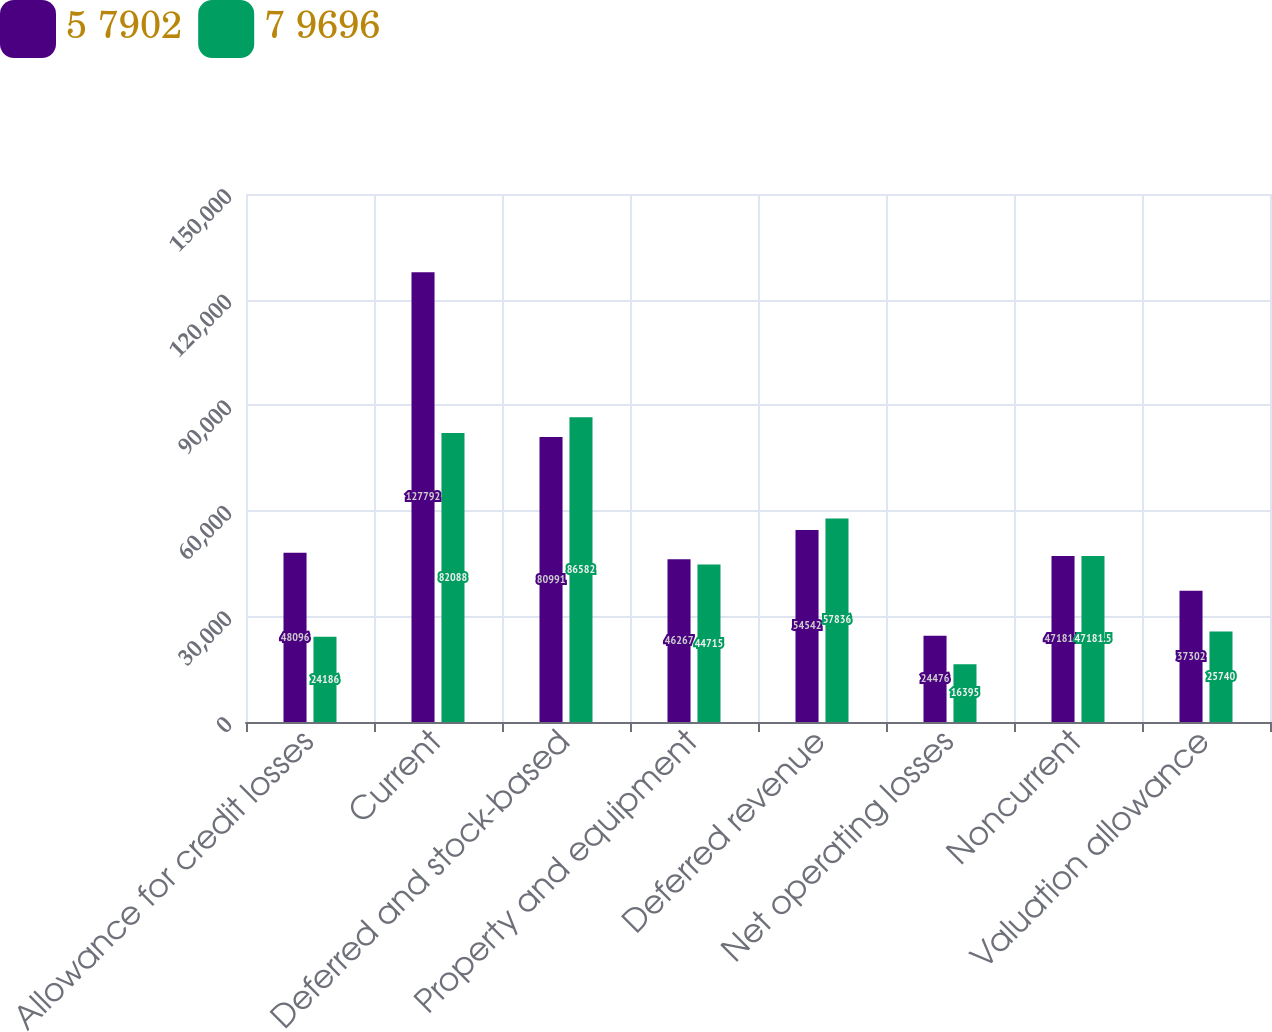Convert chart. <chart><loc_0><loc_0><loc_500><loc_500><stacked_bar_chart><ecel><fcel>Allowance for credit losses<fcel>Current<fcel>Deferred and stock-based<fcel>Property and equipment<fcel>Deferred revenue<fcel>Net operating losses<fcel>Noncurrent<fcel>Valuation allowance<nl><fcel>5 7902<fcel>48096<fcel>127792<fcel>80991<fcel>46267<fcel>54542<fcel>24476<fcel>47181.5<fcel>37302<nl><fcel>7 9696<fcel>24186<fcel>82088<fcel>86582<fcel>44715<fcel>57836<fcel>16395<fcel>47181.5<fcel>25740<nl></chart> 